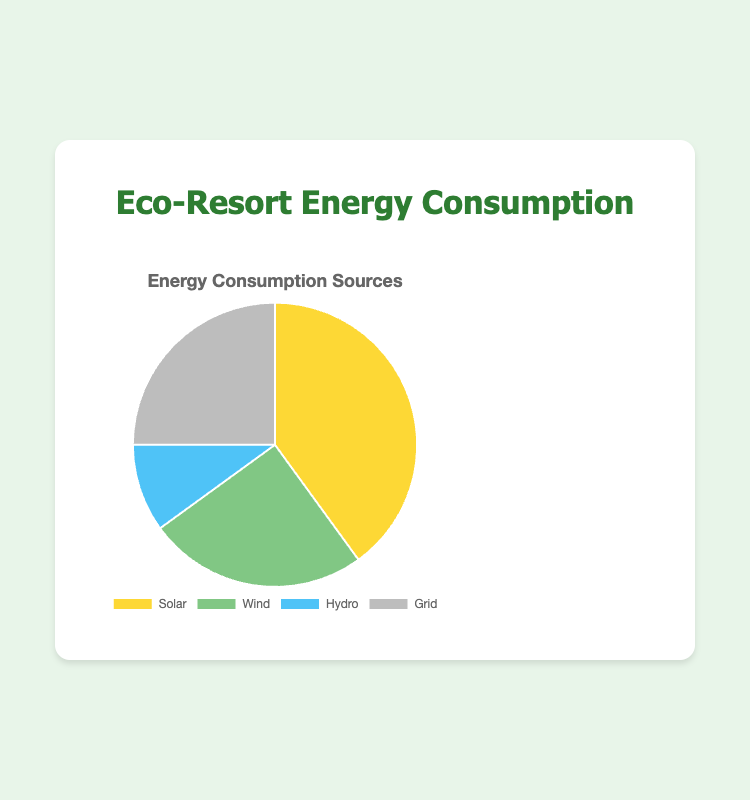What is the largest source of energy consumption in the resort? By looking at the pie chart, identify the segment with the largest percentage value. The segment labeled 'Solar' has a consumption percentage of 40%, which is the highest.
Answer: Solar What is the combined percentage of Wind and Grid energy consumption? Add the consumption percentages of Wind (25%) and Grid (25%) from the pie chart. 25% + 25% = 50%.
Answer: 50% Which source has the lowest energy consumption? By examining the pie chart, the smallest segment belongs to 'Hydro', which indicates a consumption percentage of 10%.
Answer: Hydro How much higher is Solar energy consumption compared to Hydro energy consumption? Subtract the consumption percentage of Hydro (10%) from Solar (40%). 40% - 10% = 30%.
Answer: 30% What is the difference between the Wind and Grid energy consumption percentages? Both Wind and Grid have a consumption percentage of 25%. Therefore, the difference is 25% - 25% = 0%.
Answer: 0% Which two energy sources have the same consumption percentage? By reviewing the pie chart, it is clear that both Wind and Grid have the same consumption percentage of 25%.
Answer: Wind and Grid What is the average consumption percentage of Solar, Wind, and Hydro? Sum the percentages of Solar (40%), Wind (25%), and Hydro (10%) and divide by the number of sources (3). (40% + 25% + 10%) / 3 ≈ 25%.
Answer: 25% What color represents the energy consumption from the Wind source? Match the color of the segment labeled 'Wind' in the pie chart with its description. The color is green.
Answer: Green Which energy source combines with Solar to make up more than half of the total energy consumption? Adding Solar (40%) with any other source, only Wind (25%) and Grid (25%) combined with Solar exceed 50%. 40% + 25% (for either Wind or Grid) = 65%.
Answer: Wind or Grid 